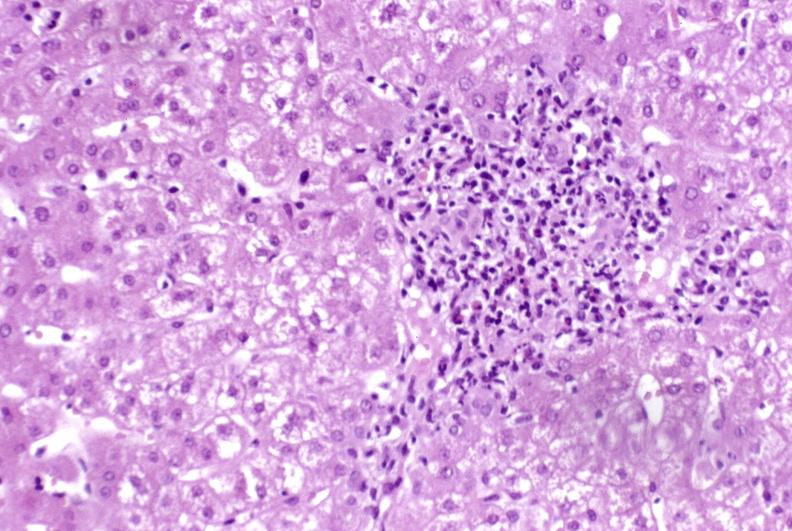s hypertension present?
Answer the question using a single word or phrase. No 